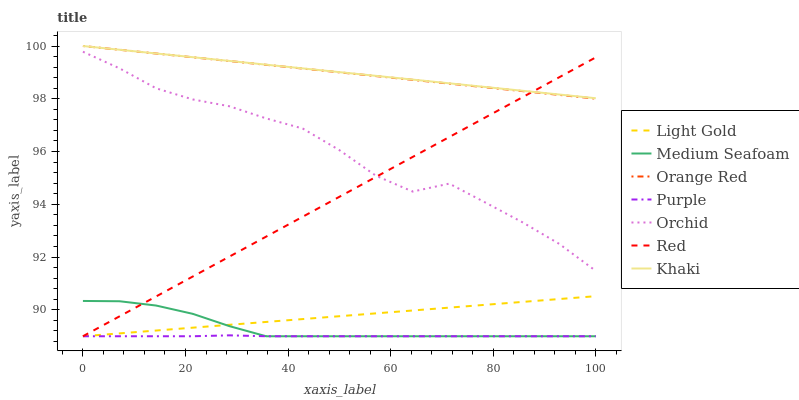Does Purple have the minimum area under the curve?
Answer yes or no. Yes. Does Khaki have the maximum area under the curve?
Answer yes or no. Yes. Does Orange Red have the minimum area under the curve?
Answer yes or no. No. Does Orange Red have the maximum area under the curve?
Answer yes or no. No. Is Khaki the smoothest?
Answer yes or no. Yes. Is Orchid the roughest?
Answer yes or no. Yes. Is Purple the smoothest?
Answer yes or no. No. Is Purple the roughest?
Answer yes or no. No. Does Purple have the lowest value?
Answer yes or no. Yes. Does Orange Red have the lowest value?
Answer yes or no. No. Does Orange Red have the highest value?
Answer yes or no. Yes. Does Purple have the highest value?
Answer yes or no. No. Is Light Gold less than Orchid?
Answer yes or no. Yes. Is Orange Red greater than Light Gold?
Answer yes or no. Yes. Does Orange Red intersect Khaki?
Answer yes or no. Yes. Is Orange Red less than Khaki?
Answer yes or no. No. Is Orange Red greater than Khaki?
Answer yes or no. No. Does Light Gold intersect Orchid?
Answer yes or no. No. 